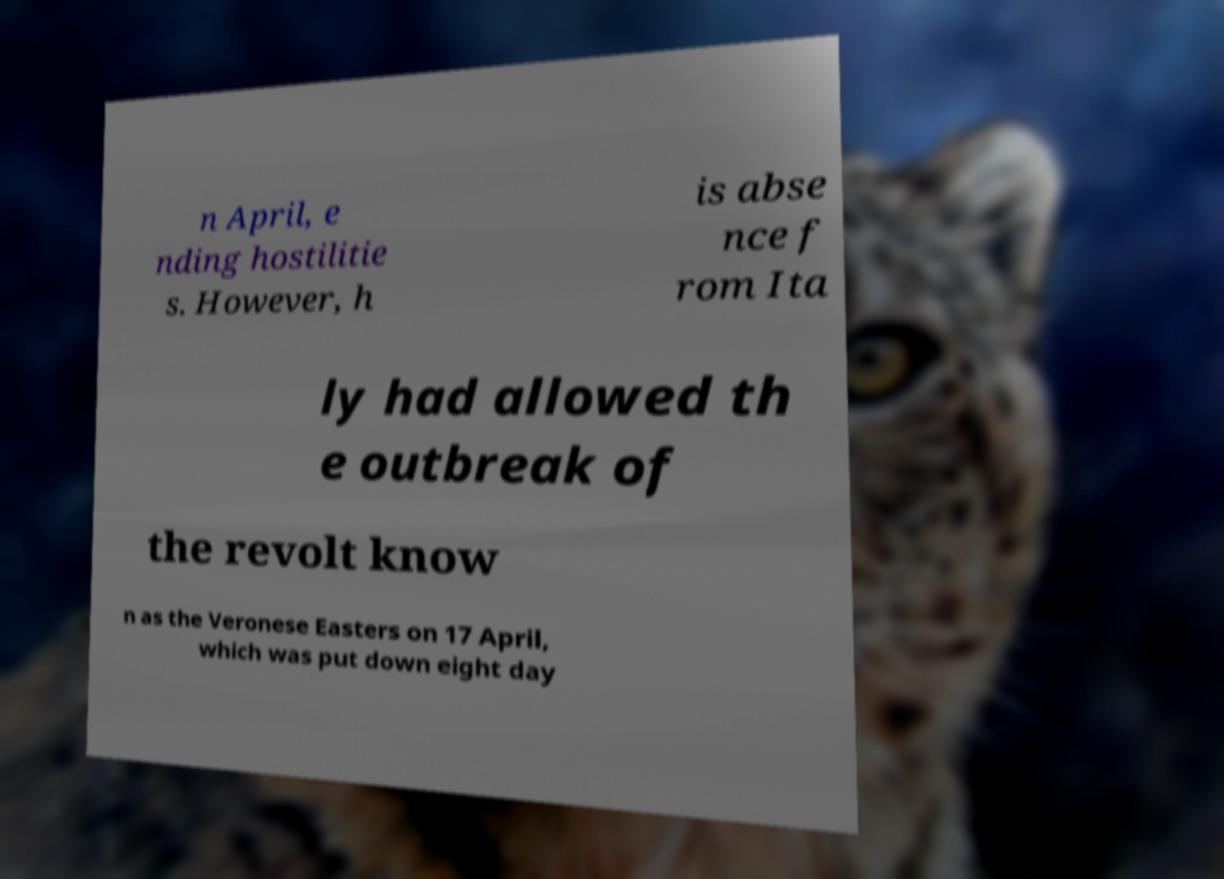There's text embedded in this image that I need extracted. Can you transcribe it verbatim? n April, e nding hostilitie s. However, h is abse nce f rom Ita ly had allowed th e outbreak of the revolt know n as the Veronese Easters on 17 April, which was put down eight day 